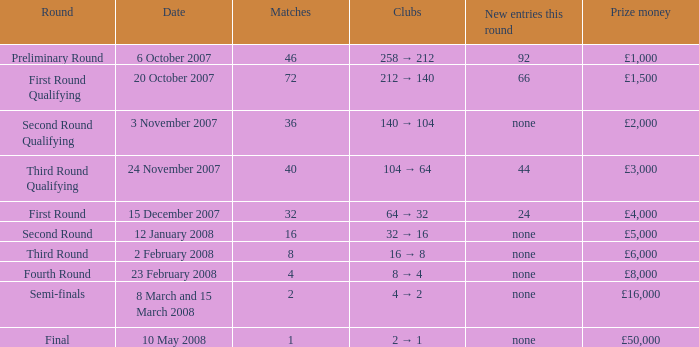What is the average for matches with a prize money amount of £3,000? 40.0. 